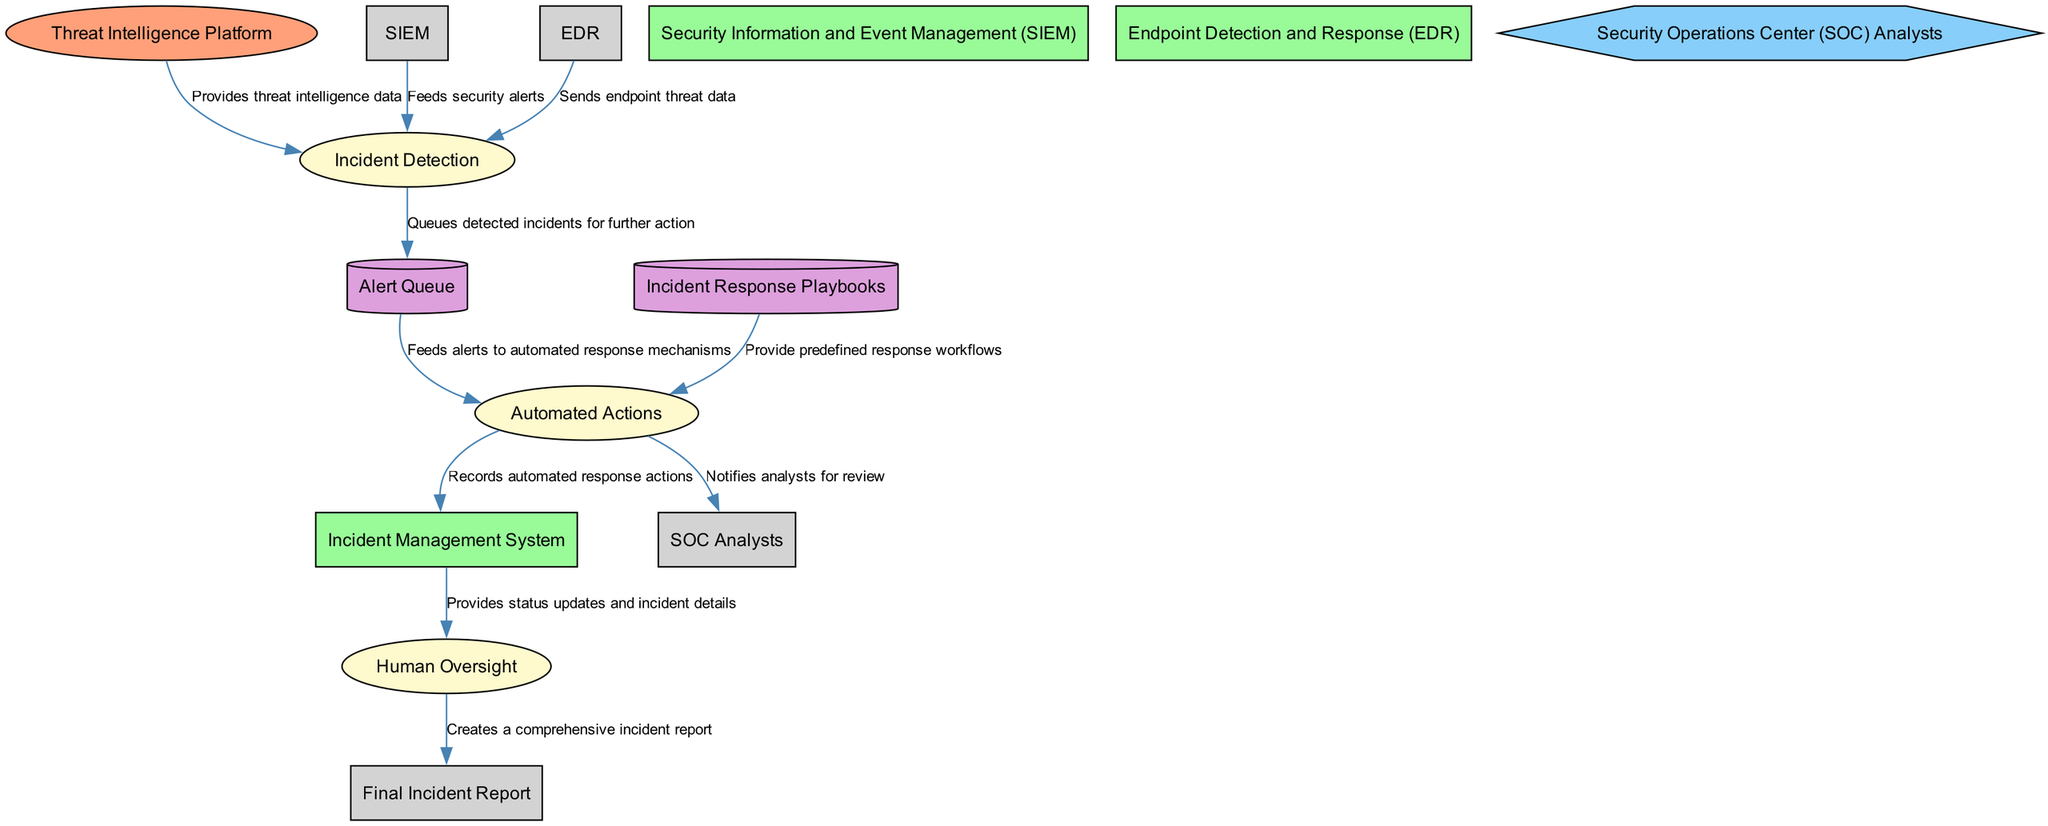What entity feeds threat intelligence data into the SOAR system? The diagram indicates that the "Threat Intelligence Platform" is the entity providing threat intelligence data to the Incident Detection process.
Answer: Threat Intelligence Platform How many data stores are present in the diagram? By analyzing the diagram, we can count two data stores, which are "Incident Response Playbooks" and "Alert Queue."
Answer: 2 What is the first process in the workflow? The diagram shows that the first process is "Incident Detection," which detects potential security incidents based on incoming data.
Answer: Incident Detection What outputs are generated from the "Automated Actions" process? Looking at the outputs of the "Automated Actions" process, we find that it generates outputs to both the "Incident Management System" and "SOC Analysts."
Answer: Incident Management System, SOC Analysts Who performs human oversight during the incident response? The diagram shows that "SOC Analysts" are responsible for reviewing the automated actions and providing human oversight.
Answer: SOC Analysts What is the role of the "Alert Queue" in the diagram? The "Alert Queue" functions as a holding area for security alerts that await further processing by the Automated Actions system.
Answer: Queues detected incidents for further action What relationship exists between the "Incident Management System" and "Human Oversight"? The "Incident Management System" provides status updates and incident details as inputs to the "Human Oversight" process, suggesting a direct relationship for review purposes.
Answer: Provides status updates and incident details Which process is responsible for executing automated response actions based on predefined playbooks? The process labeled "Automated Actions" is solely responsible for executing these automated response actions according to the incident response playbooks.
Answer: Automated Actions What is created as a result of the "Human Oversight"? The output of the "Human Oversight" process is a "Final Incident Report," summarizing the findings and status of the incident.
Answer: Final Incident Report 